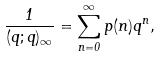<formula> <loc_0><loc_0><loc_500><loc_500>\frac { 1 } { ( q ; q ) _ { \infty } } = \sum _ { n = 0 } ^ { \infty } p ( n ) q ^ { n } ,</formula> 